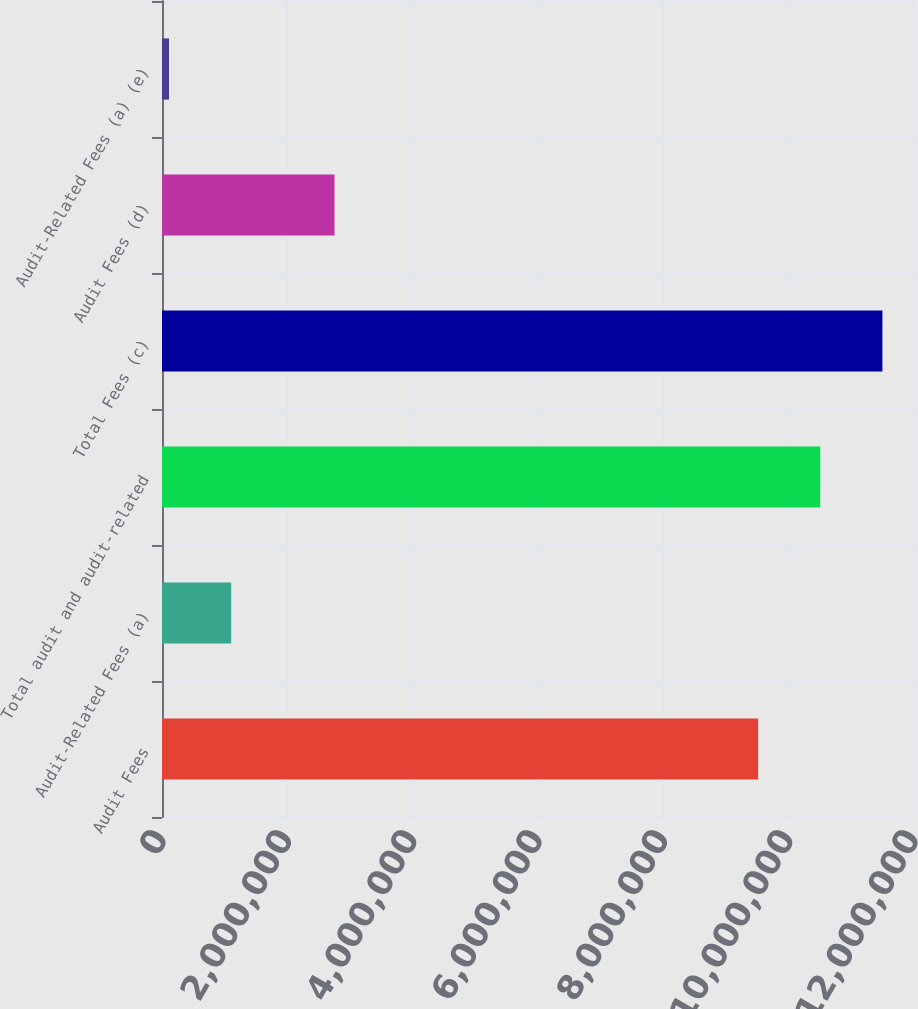<chart> <loc_0><loc_0><loc_500><loc_500><bar_chart><fcel>Audit Fees<fcel>Audit-Related Fees (a)<fcel>Total audit and audit-related<fcel>Total Fees (c)<fcel>Audit Fees (d)<fcel>Audit-Related Fees (a) (e)<nl><fcel>9.51224e+06<fcel>1.10395e+06<fcel>1.05042e+07<fcel>1.14961e+07<fcel>2.753e+06<fcel>112000<nl></chart> 